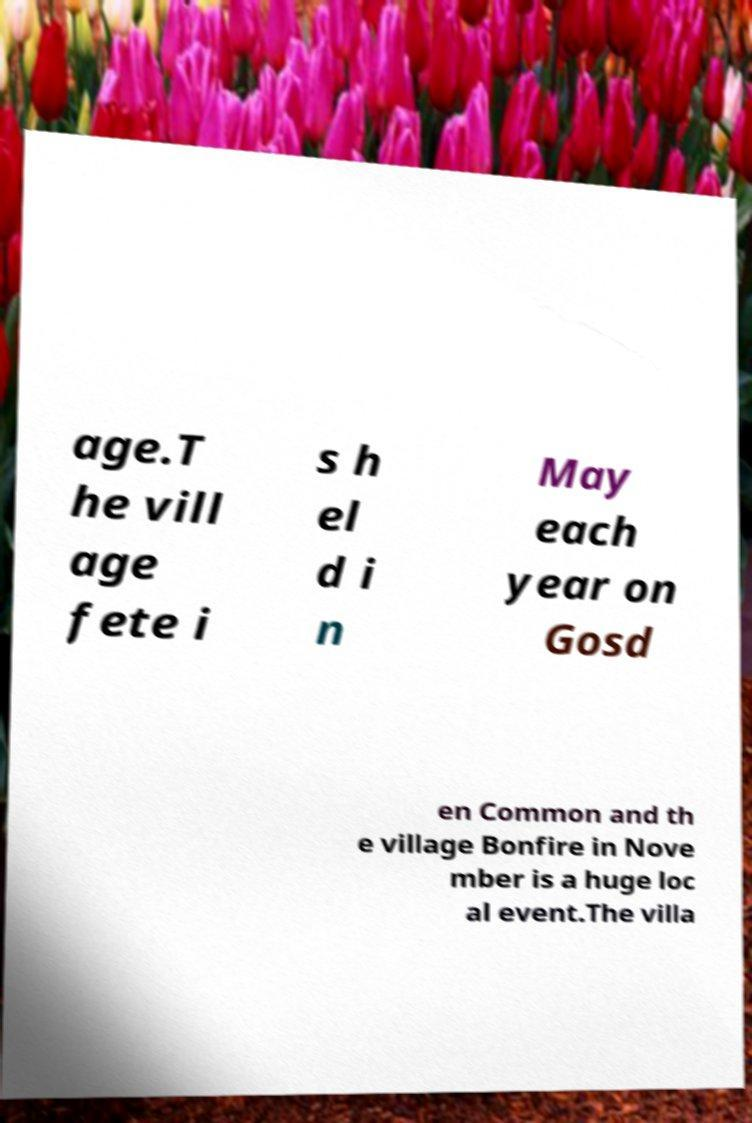Can you read and provide the text displayed in the image?This photo seems to have some interesting text. Can you extract and type it out for me? age.T he vill age fete i s h el d i n May each year on Gosd en Common and th e village Bonfire in Nove mber is a huge loc al event.The villa 